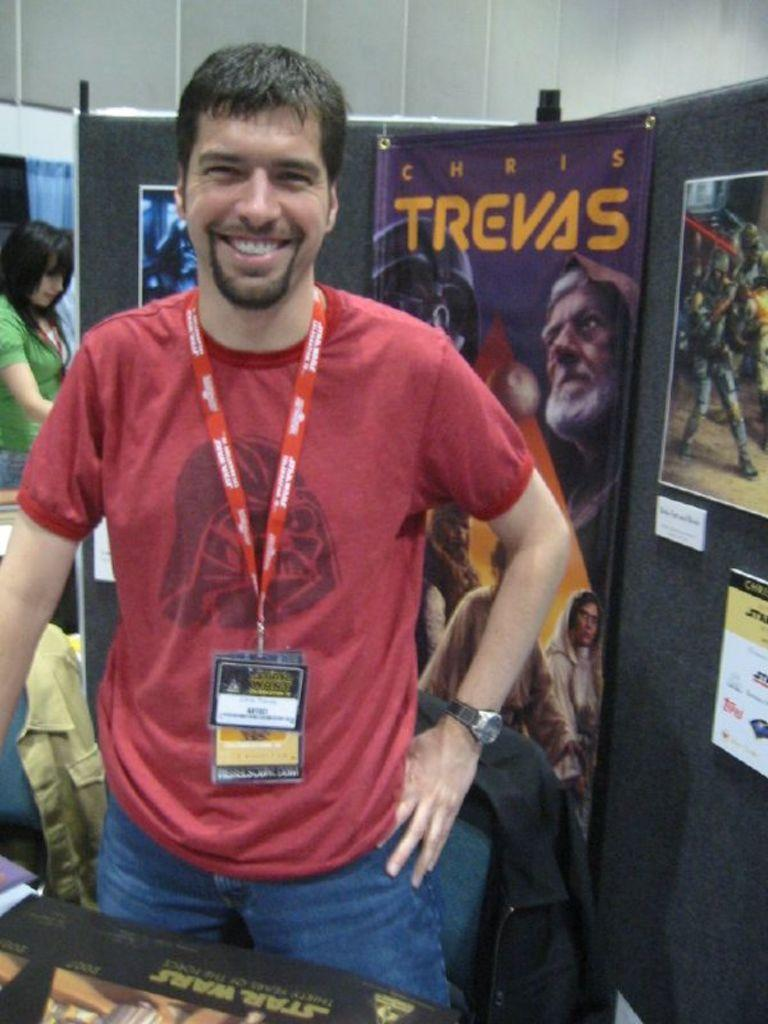<image>
Relay a brief, clear account of the picture shown. A smiling mans wearing red tee is standing in front of the purple Chris Trevas poster. 